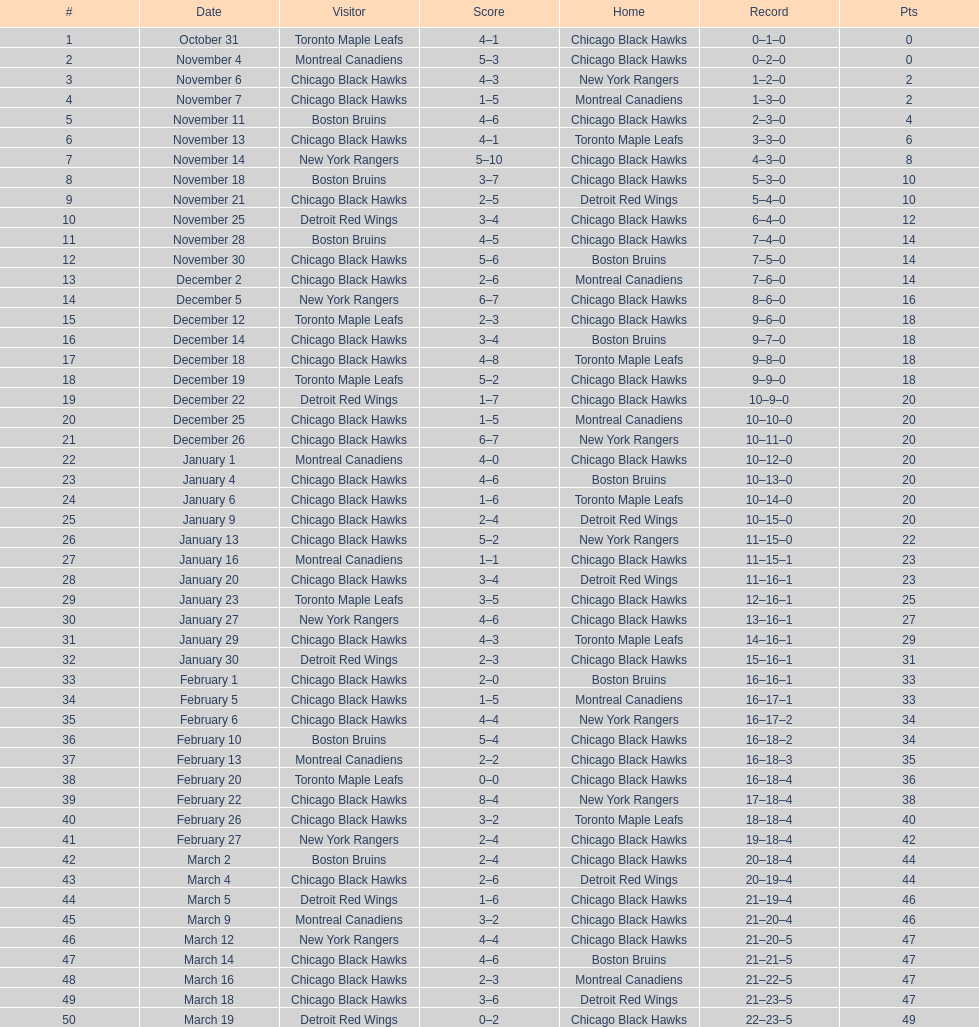What is the point difference between december 5th and november 11th? 3. 